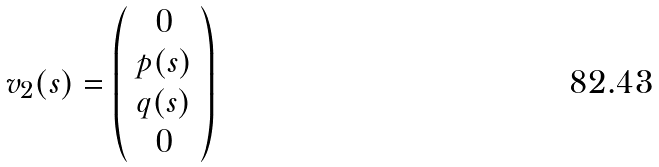<formula> <loc_0><loc_0><loc_500><loc_500>v _ { 2 } ( s ) = \left ( \begin{array} { c } 0 \\ p ( s ) \\ q ( s ) \\ 0 \end{array} \right )</formula> 